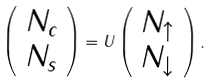Convert formula to latex. <formula><loc_0><loc_0><loc_500><loc_500>\left ( \begin{array} { c } N _ { c } \\ N _ { s } \end{array} \right ) = U \left ( \begin{array} { c } N _ { \uparrow } \\ N _ { \downarrow } \end{array} \right ) .</formula> 